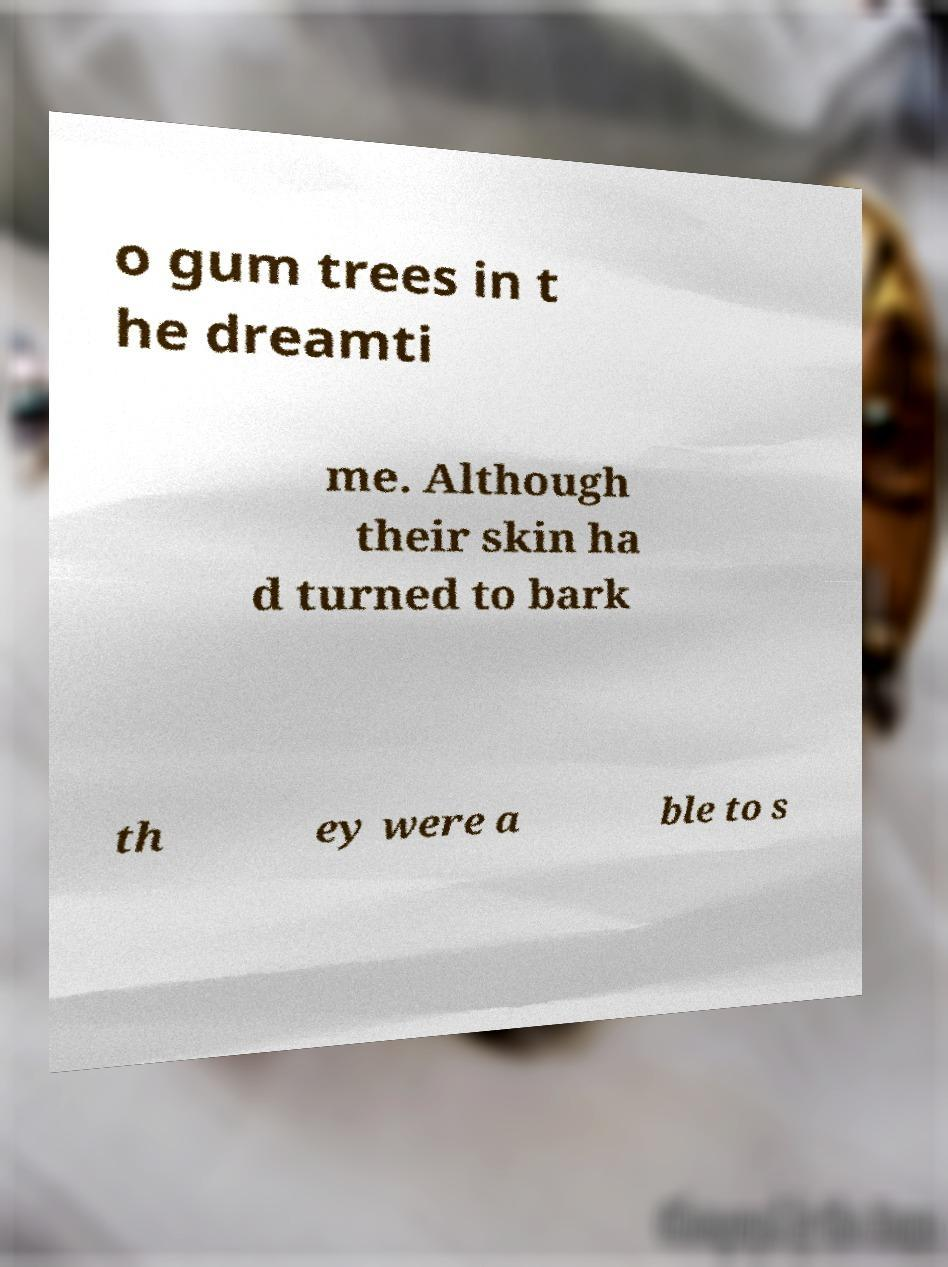Can you accurately transcribe the text from the provided image for me? o gum trees in t he dreamti me. Although their skin ha d turned to bark th ey were a ble to s 